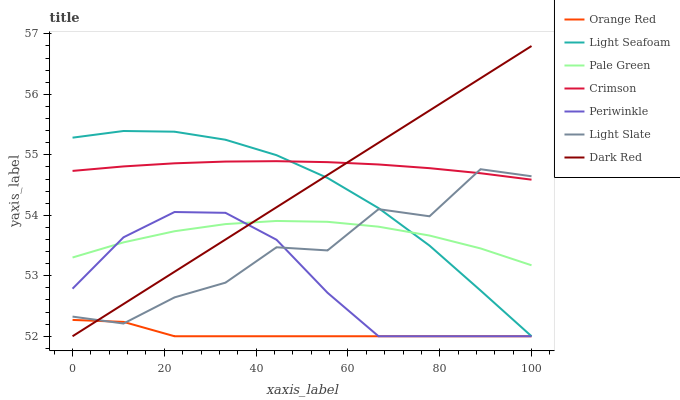Does Orange Red have the minimum area under the curve?
Answer yes or no. Yes. Does Crimson have the maximum area under the curve?
Answer yes or no. Yes. Does Dark Red have the minimum area under the curve?
Answer yes or no. No. Does Dark Red have the maximum area under the curve?
Answer yes or no. No. Is Dark Red the smoothest?
Answer yes or no. Yes. Is Light Slate the roughest?
Answer yes or no. Yes. Is Pale Green the smoothest?
Answer yes or no. No. Is Pale Green the roughest?
Answer yes or no. No. Does Dark Red have the lowest value?
Answer yes or no. Yes. Does Pale Green have the lowest value?
Answer yes or no. No. Does Dark Red have the highest value?
Answer yes or no. Yes. Does Pale Green have the highest value?
Answer yes or no. No. Is Pale Green less than Crimson?
Answer yes or no. Yes. Is Crimson greater than Orange Red?
Answer yes or no. Yes. Does Orange Red intersect Periwinkle?
Answer yes or no. Yes. Is Orange Red less than Periwinkle?
Answer yes or no. No. Is Orange Red greater than Periwinkle?
Answer yes or no. No. Does Pale Green intersect Crimson?
Answer yes or no. No. 